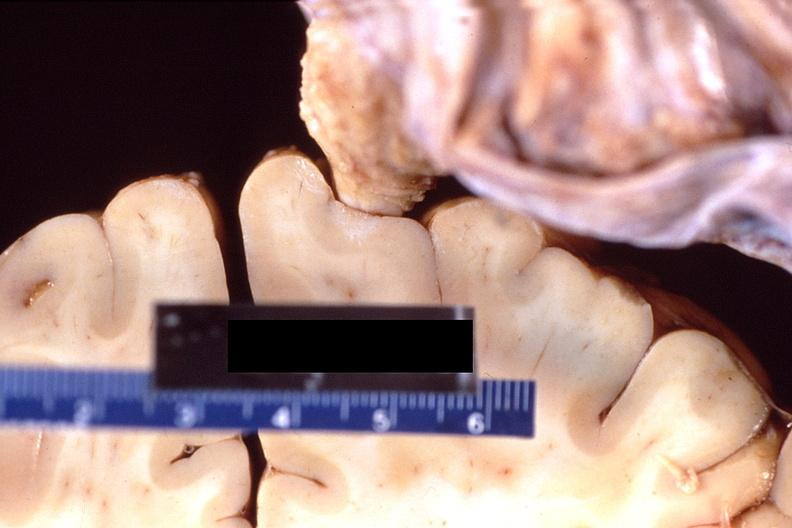what is present?
Answer the question using a single word or phrase. Nervous 